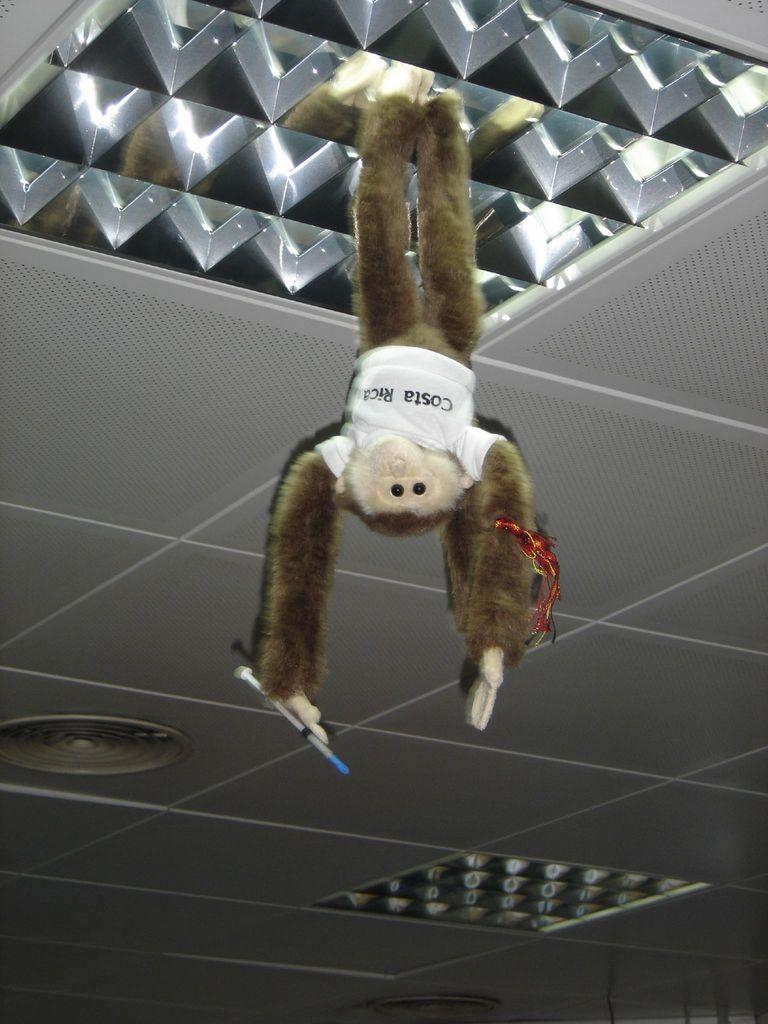What is hanging at the top of the image? There is a toy hanging at the top of the image. What is above the toy in the image? There is a ceiling in the image. What can be seen in the image besides the toy and ceiling? There are lights visible in the image. What type of honey is being collected by the giants in the image? There are no giants or honey present in the image. 